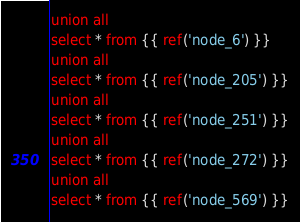Convert code to text. <code><loc_0><loc_0><loc_500><loc_500><_SQL_>union all
select * from {{ ref('node_6') }}
union all
select * from {{ ref('node_205') }}
union all
select * from {{ ref('node_251') }}
union all
select * from {{ ref('node_272') }}
union all
select * from {{ ref('node_569') }}
</code> 